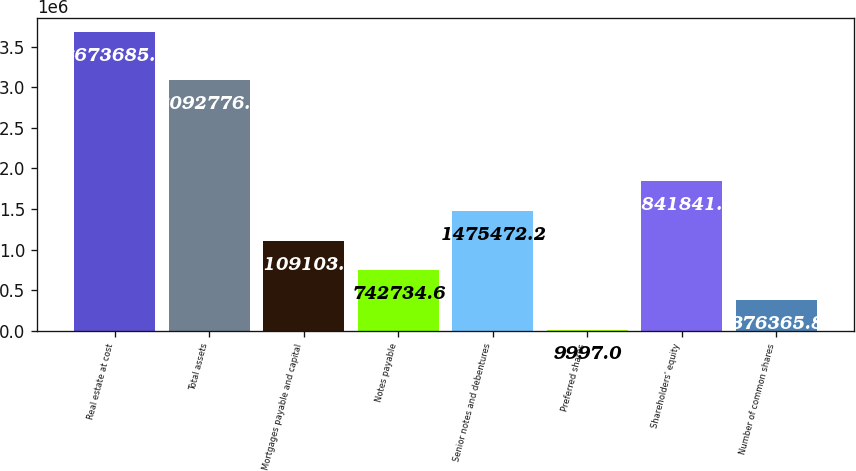Convert chart. <chart><loc_0><loc_0><loc_500><loc_500><bar_chart><fcel>Real estate at cost<fcel>Total assets<fcel>Mortgages payable and capital<fcel>Notes payable<fcel>Senior notes and debentures<fcel>Preferred shares<fcel>Shareholders' equity<fcel>Number of common shares<nl><fcel>3.67368e+06<fcel>3.09278e+06<fcel>1.1091e+06<fcel>742735<fcel>1.47547e+06<fcel>9997<fcel>1.84184e+06<fcel>376366<nl></chart> 